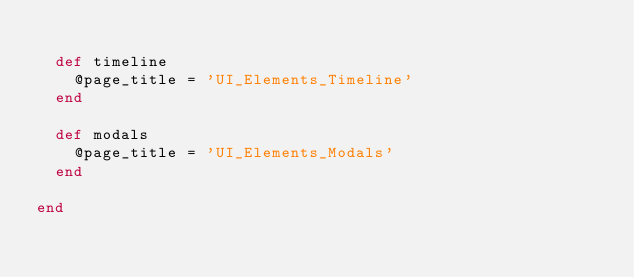<code> <loc_0><loc_0><loc_500><loc_500><_Ruby_>
  def timeline
    @page_title = 'UI_Elements_Timeline'
  end

  def modals
    @page_title = 'UI_Elements_Modals'
  end

end
</code> 